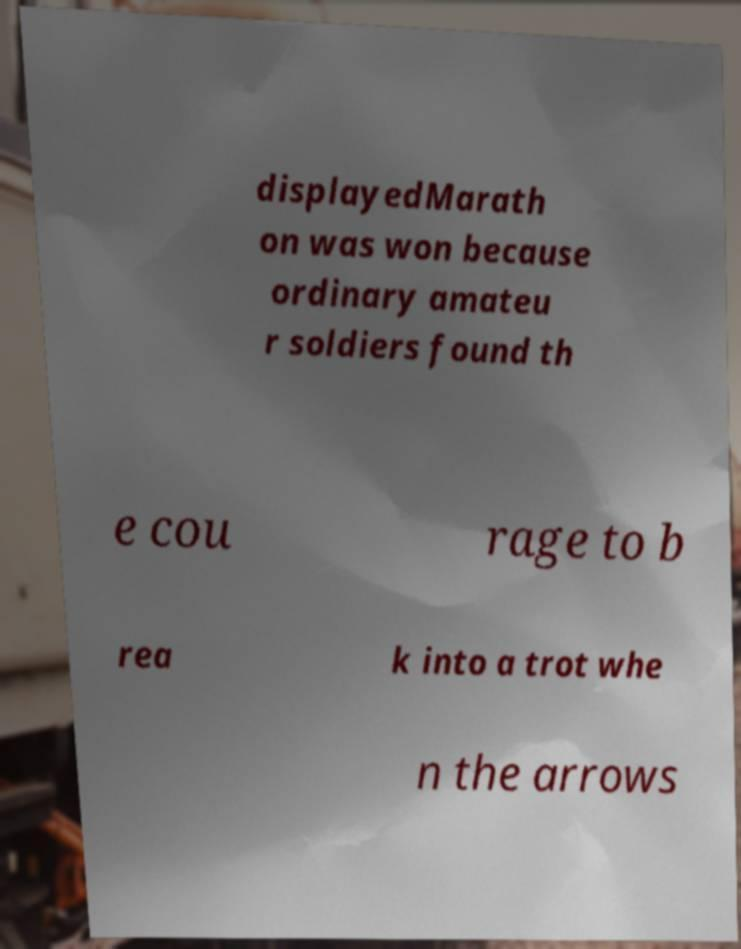Please read and relay the text visible in this image. What does it say? displayedMarath on was won because ordinary amateu r soldiers found th e cou rage to b rea k into a trot whe n the arrows 